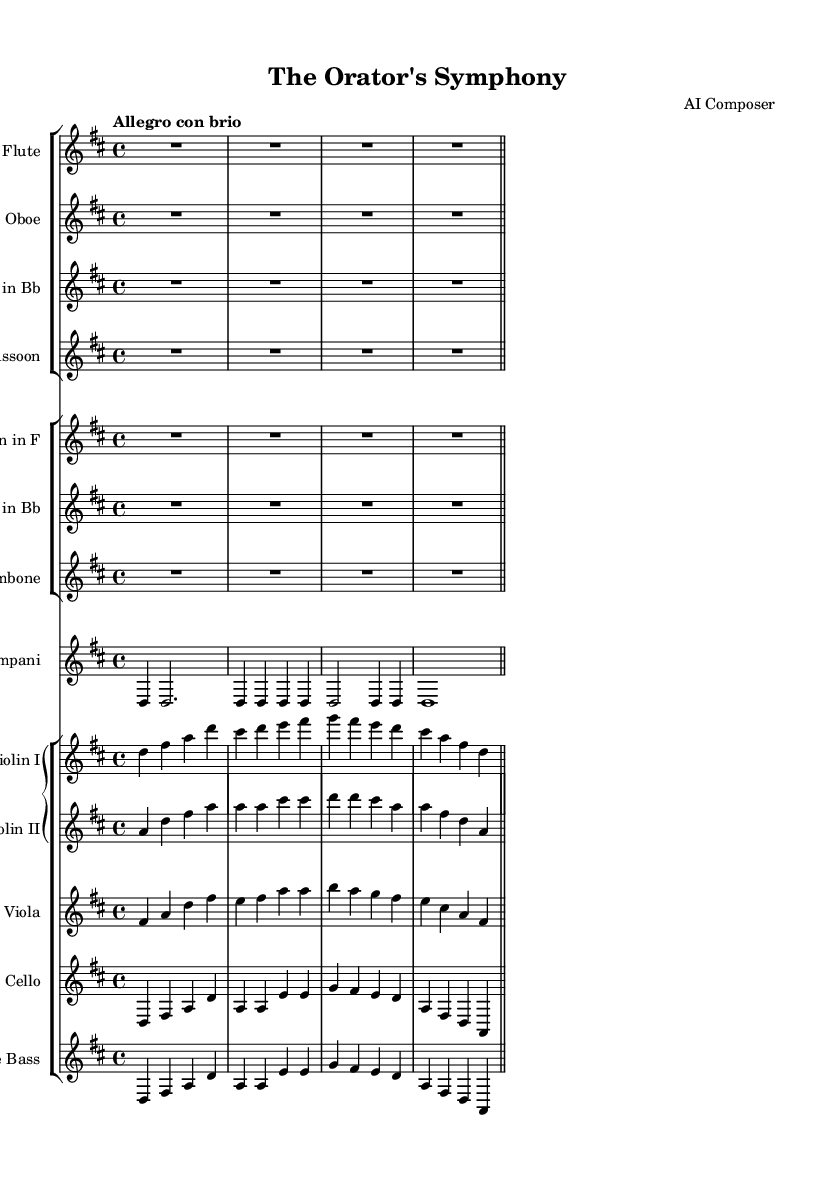What is the key signature of this music? The key signature is indicated at the beginning of the staff, showing two sharps which represent F# and C#. Thus, the key is D major.
Answer: D major What is the time signature of this piece? The time signature is presented as 4/4 at the beginning of the staff, indicating four beats per measure with a quarter note representing one beat.
Answer: 4/4 What is the tempo marking for the symphony? The tempo marking is found at the start of the sheet music as "Allegro con brio," which translates to a lively pace, typically around 120 to 168 beats per minute.
Answer: Allegro con brio How many instruments are featured in this symphony? By reviewing the staff groups, there are a total of ten distinct instruments listed: Flute, Oboe, Clarinet in Bb, Bassoon, Horn in F, Trumpet in Bb, Trombone, Timpani, Violin I, Violin II, Viola, Cello, and Double Bass. In total, including all listed; however, in the groups, there are 8 unique parts named separately with Timpani counted individually.
Answer: 13 What instruments are doubling the string parts in this symphony? The violins and other strings are emphasized by brass and woodwind sections, but specifically, there are no direct doubling indicated within the parts as each plays their own distinct role. However, for rich texture, the Timpani can also support the strings rhythmically in dynamic crescendi.
Answer: None Which voices or instruments have rests in the first measure? The first measure indicates that Flute, Oboe, Clarinet, Bassoon, Horn, Trumpet, Trombone, and Timpani have no played notes (represented by R1*4 for rest) all showing as full measure rests in the first beat of each respective staff.
Answer: All wind instruments and Timpani 